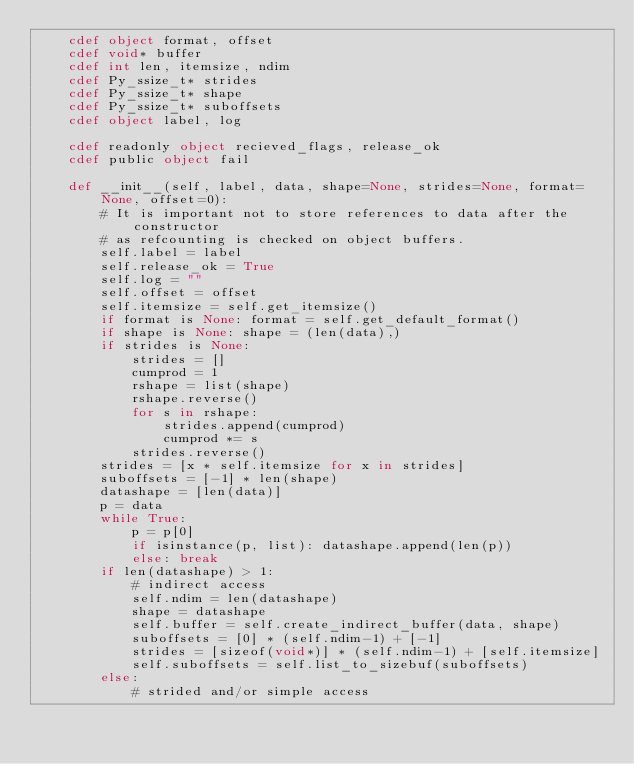Convert code to text. <code><loc_0><loc_0><loc_500><loc_500><_Cython_>    cdef object format, offset
    cdef void* buffer
    cdef int len, itemsize, ndim
    cdef Py_ssize_t* strides
    cdef Py_ssize_t* shape
    cdef Py_ssize_t* suboffsets
    cdef object label, log

    cdef readonly object recieved_flags, release_ok
    cdef public object fail

    def __init__(self, label, data, shape=None, strides=None, format=None, offset=0):
        # It is important not to store references to data after the constructor
        # as refcounting is checked on object buffers.
        self.label = label
        self.release_ok = True
        self.log = ""
        self.offset = offset
        self.itemsize = self.get_itemsize()
        if format is None: format = self.get_default_format()
        if shape is None: shape = (len(data),)
        if strides is None:
            strides = []
            cumprod = 1
            rshape = list(shape)
            rshape.reverse()
            for s in rshape:
                strides.append(cumprod)
                cumprod *= s
            strides.reverse()
        strides = [x * self.itemsize for x in strides]
        suboffsets = [-1] * len(shape)
        datashape = [len(data)]
        p = data
        while True:
            p = p[0]
            if isinstance(p, list): datashape.append(len(p))
            else: break
        if len(datashape) > 1:
            # indirect access
            self.ndim = len(datashape)
            shape = datashape
            self.buffer = self.create_indirect_buffer(data, shape)
            suboffsets = [0] * (self.ndim-1) + [-1]
            strides = [sizeof(void*)] * (self.ndim-1) + [self.itemsize]
            self.suboffsets = self.list_to_sizebuf(suboffsets)
        else:
            # strided and/or simple access</code> 